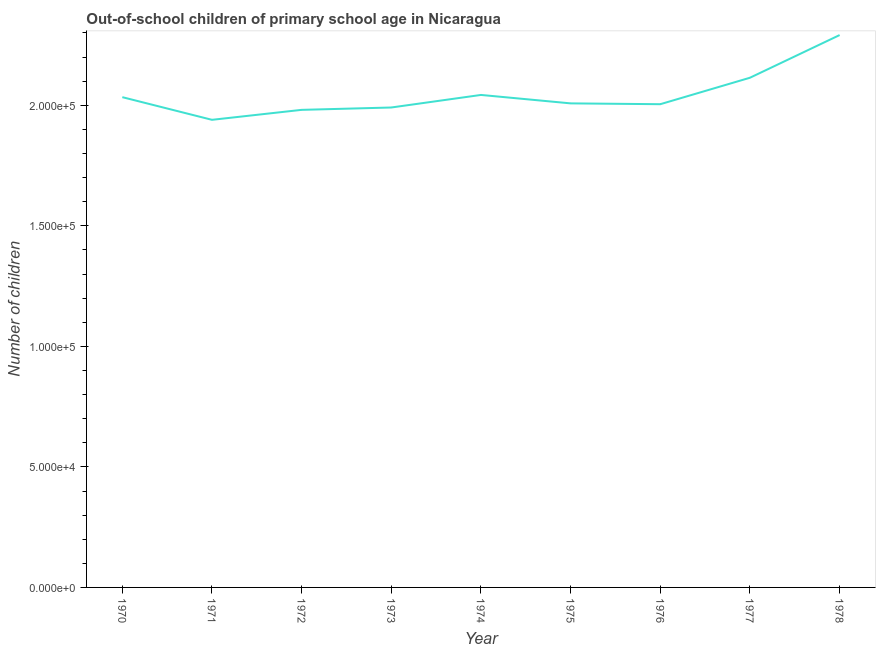What is the number of out-of-school children in 1975?
Keep it short and to the point. 2.01e+05. Across all years, what is the maximum number of out-of-school children?
Provide a short and direct response. 2.29e+05. Across all years, what is the minimum number of out-of-school children?
Make the answer very short. 1.94e+05. In which year was the number of out-of-school children maximum?
Give a very brief answer. 1978. In which year was the number of out-of-school children minimum?
Offer a very short reply. 1971. What is the sum of the number of out-of-school children?
Provide a short and direct response. 1.84e+06. What is the difference between the number of out-of-school children in 1974 and 1977?
Provide a short and direct response. -7136. What is the average number of out-of-school children per year?
Offer a very short reply. 2.05e+05. What is the median number of out-of-school children?
Your answer should be very brief. 2.01e+05. What is the ratio of the number of out-of-school children in 1972 to that in 1975?
Your response must be concise. 0.99. Is the number of out-of-school children in 1973 less than that in 1976?
Offer a very short reply. Yes. Is the difference between the number of out-of-school children in 1973 and 1975 greater than the difference between any two years?
Offer a very short reply. No. What is the difference between the highest and the second highest number of out-of-school children?
Give a very brief answer. 1.77e+04. What is the difference between the highest and the lowest number of out-of-school children?
Your response must be concise. 3.52e+04. How many lines are there?
Your answer should be very brief. 1. How many years are there in the graph?
Keep it short and to the point. 9. Does the graph contain any zero values?
Ensure brevity in your answer.  No. Does the graph contain grids?
Your answer should be compact. No. What is the title of the graph?
Keep it short and to the point. Out-of-school children of primary school age in Nicaragua. What is the label or title of the Y-axis?
Offer a terse response. Number of children. What is the Number of children of 1970?
Provide a succinct answer. 2.03e+05. What is the Number of children of 1971?
Your answer should be compact. 1.94e+05. What is the Number of children of 1972?
Make the answer very short. 1.98e+05. What is the Number of children of 1973?
Your answer should be very brief. 1.99e+05. What is the Number of children in 1974?
Make the answer very short. 2.04e+05. What is the Number of children in 1975?
Make the answer very short. 2.01e+05. What is the Number of children of 1976?
Make the answer very short. 2.00e+05. What is the Number of children in 1977?
Offer a terse response. 2.11e+05. What is the Number of children in 1978?
Give a very brief answer. 2.29e+05. What is the difference between the Number of children in 1970 and 1971?
Your answer should be very brief. 9401. What is the difference between the Number of children in 1970 and 1972?
Offer a terse response. 5268. What is the difference between the Number of children in 1970 and 1973?
Ensure brevity in your answer.  4289. What is the difference between the Number of children in 1970 and 1974?
Your answer should be compact. -919. What is the difference between the Number of children in 1970 and 1975?
Your answer should be compact. 2580. What is the difference between the Number of children in 1970 and 1976?
Give a very brief answer. 2922. What is the difference between the Number of children in 1970 and 1977?
Keep it short and to the point. -8055. What is the difference between the Number of children in 1970 and 1978?
Keep it short and to the point. -2.58e+04. What is the difference between the Number of children in 1971 and 1972?
Ensure brevity in your answer.  -4133. What is the difference between the Number of children in 1971 and 1973?
Offer a terse response. -5112. What is the difference between the Number of children in 1971 and 1974?
Provide a succinct answer. -1.03e+04. What is the difference between the Number of children in 1971 and 1975?
Your response must be concise. -6821. What is the difference between the Number of children in 1971 and 1976?
Your answer should be compact. -6479. What is the difference between the Number of children in 1971 and 1977?
Keep it short and to the point. -1.75e+04. What is the difference between the Number of children in 1971 and 1978?
Provide a succinct answer. -3.52e+04. What is the difference between the Number of children in 1972 and 1973?
Provide a short and direct response. -979. What is the difference between the Number of children in 1972 and 1974?
Your response must be concise. -6187. What is the difference between the Number of children in 1972 and 1975?
Keep it short and to the point. -2688. What is the difference between the Number of children in 1972 and 1976?
Keep it short and to the point. -2346. What is the difference between the Number of children in 1972 and 1977?
Your answer should be very brief. -1.33e+04. What is the difference between the Number of children in 1972 and 1978?
Your answer should be very brief. -3.10e+04. What is the difference between the Number of children in 1973 and 1974?
Ensure brevity in your answer.  -5208. What is the difference between the Number of children in 1973 and 1975?
Ensure brevity in your answer.  -1709. What is the difference between the Number of children in 1973 and 1976?
Make the answer very short. -1367. What is the difference between the Number of children in 1973 and 1977?
Offer a very short reply. -1.23e+04. What is the difference between the Number of children in 1973 and 1978?
Your response must be concise. -3.00e+04. What is the difference between the Number of children in 1974 and 1975?
Ensure brevity in your answer.  3499. What is the difference between the Number of children in 1974 and 1976?
Offer a very short reply. 3841. What is the difference between the Number of children in 1974 and 1977?
Your response must be concise. -7136. What is the difference between the Number of children in 1974 and 1978?
Provide a short and direct response. -2.48e+04. What is the difference between the Number of children in 1975 and 1976?
Your answer should be compact. 342. What is the difference between the Number of children in 1975 and 1977?
Offer a very short reply. -1.06e+04. What is the difference between the Number of children in 1975 and 1978?
Offer a very short reply. -2.83e+04. What is the difference between the Number of children in 1976 and 1977?
Your response must be concise. -1.10e+04. What is the difference between the Number of children in 1976 and 1978?
Provide a succinct answer. -2.87e+04. What is the difference between the Number of children in 1977 and 1978?
Your response must be concise. -1.77e+04. What is the ratio of the Number of children in 1970 to that in 1971?
Provide a short and direct response. 1.05. What is the ratio of the Number of children in 1970 to that in 1974?
Keep it short and to the point. 1. What is the ratio of the Number of children in 1970 to that in 1975?
Offer a terse response. 1.01. What is the ratio of the Number of children in 1970 to that in 1976?
Offer a terse response. 1.01. What is the ratio of the Number of children in 1970 to that in 1977?
Give a very brief answer. 0.96. What is the ratio of the Number of children in 1970 to that in 1978?
Give a very brief answer. 0.89. What is the ratio of the Number of children in 1971 to that in 1973?
Give a very brief answer. 0.97. What is the ratio of the Number of children in 1971 to that in 1974?
Offer a terse response. 0.95. What is the ratio of the Number of children in 1971 to that in 1975?
Keep it short and to the point. 0.97. What is the ratio of the Number of children in 1971 to that in 1976?
Offer a very short reply. 0.97. What is the ratio of the Number of children in 1971 to that in 1977?
Ensure brevity in your answer.  0.92. What is the ratio of the Number of children in 1971 to that in 1978?
Provide a succinct answer. 0.85. What is the ratio of the Number of children in 1972 to that in 1975?
Provide a short and direct response. 0.99. What is the ratio of the Number of children in 1972 to that in 1977?
Make the answer very short. 0.94. What is the ratio of the Number of children in 1972 to that in 1978?
Offer a very short reply. 0.86. What is the ratio of the Number of children in 1973 to that in 1974?
Offer a terse response. 0.97. What is the ratio of the Number of children in 1973 to that in 1976?
Your answer should be very brief. 0.99. What is the ratio of the Number of children in 1973 to that in 1977?
Make the answer very short. 0.94. What is the ratio of the Number of children in 1973 to that in 1978?
Offer a terse response. 0.87. What is the ratio of the Number of children in 1974 to that in 1975?
Offer a very short reply. 1.02. What is the ratio of the Number of children in 1974 to that in 1978?
Your answer should be compact. 0.89. What is the ratio of the Number of children in 1975 to that in 1978?
Provide a short and direct response. 0.88. What is the ratio of the Number of children in 1976 to that in 1977?
Provide a succinct answer. 0.95. What is the ratio of the Number of children in 1976 to that in 1978?
Provide a short and direct response. 0.88. What is the ratio of the Number of children in 1977 to that in 1978?
Keep it short and to the point. 0.92. 